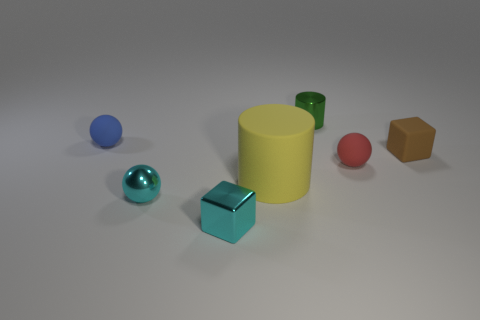Add 2 tiny purple cubes. How many objects exist? 9 Subtract all cubes. How many objects are left? 5 Subtract 0 gray spheres. How many objects are left? 7 Subtract all cyan metal cubes. Subtract all small brown cylinders. How many objects are left? 6 Add 4 green objects. How many green objects are left? 5 Add 7 cyan cubes. How many cyan cubes exist? 8 